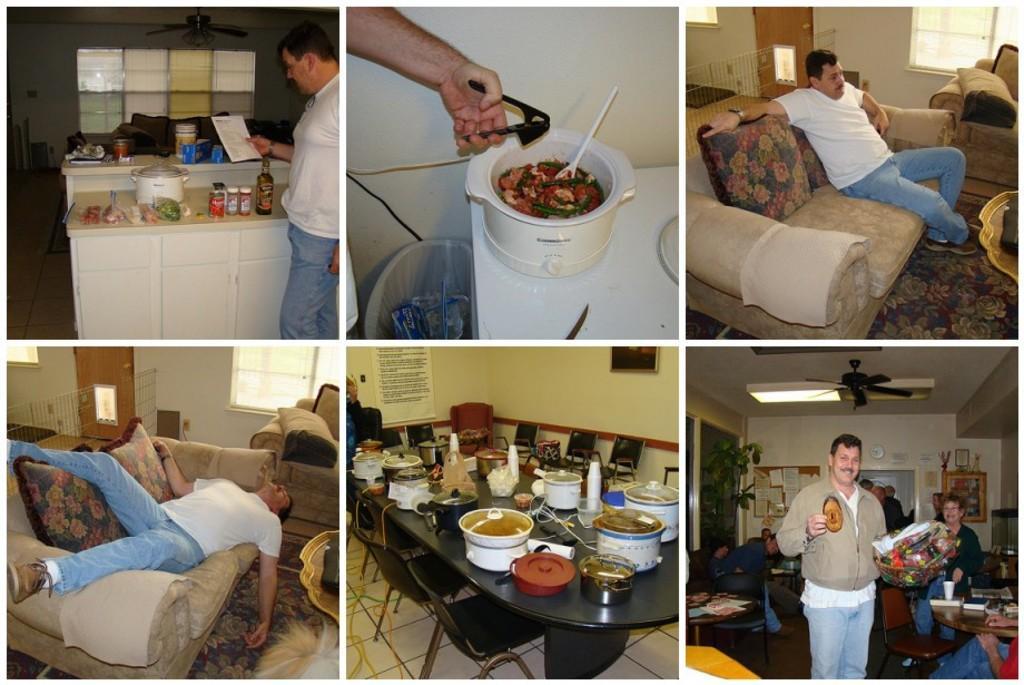How would you summarize this image in a sentence or two? We can see collage picture. This person standing and holding paper. This person sitting on the couch. This person holding things. This person laying on couch. We can see table. On the table we can see bowl,things. This is floor. We can see chairs. 